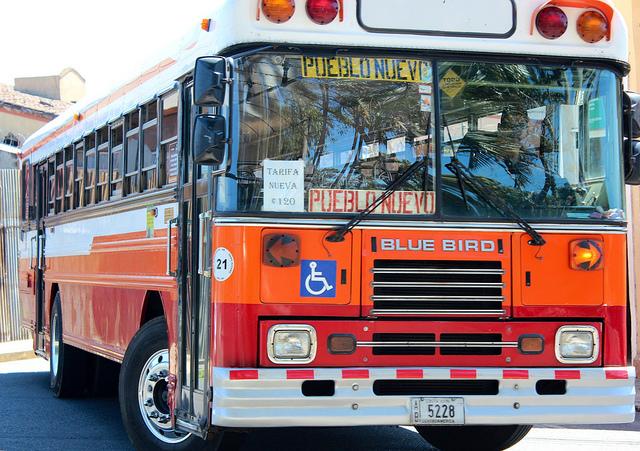Is this a Mexican bus?
Keep it brief. Yes. What vehicle is this?
Quick response, please. Bus. What does the blue square symbol on the front of the bus mean?
Give a very brief answer. Handicap. 